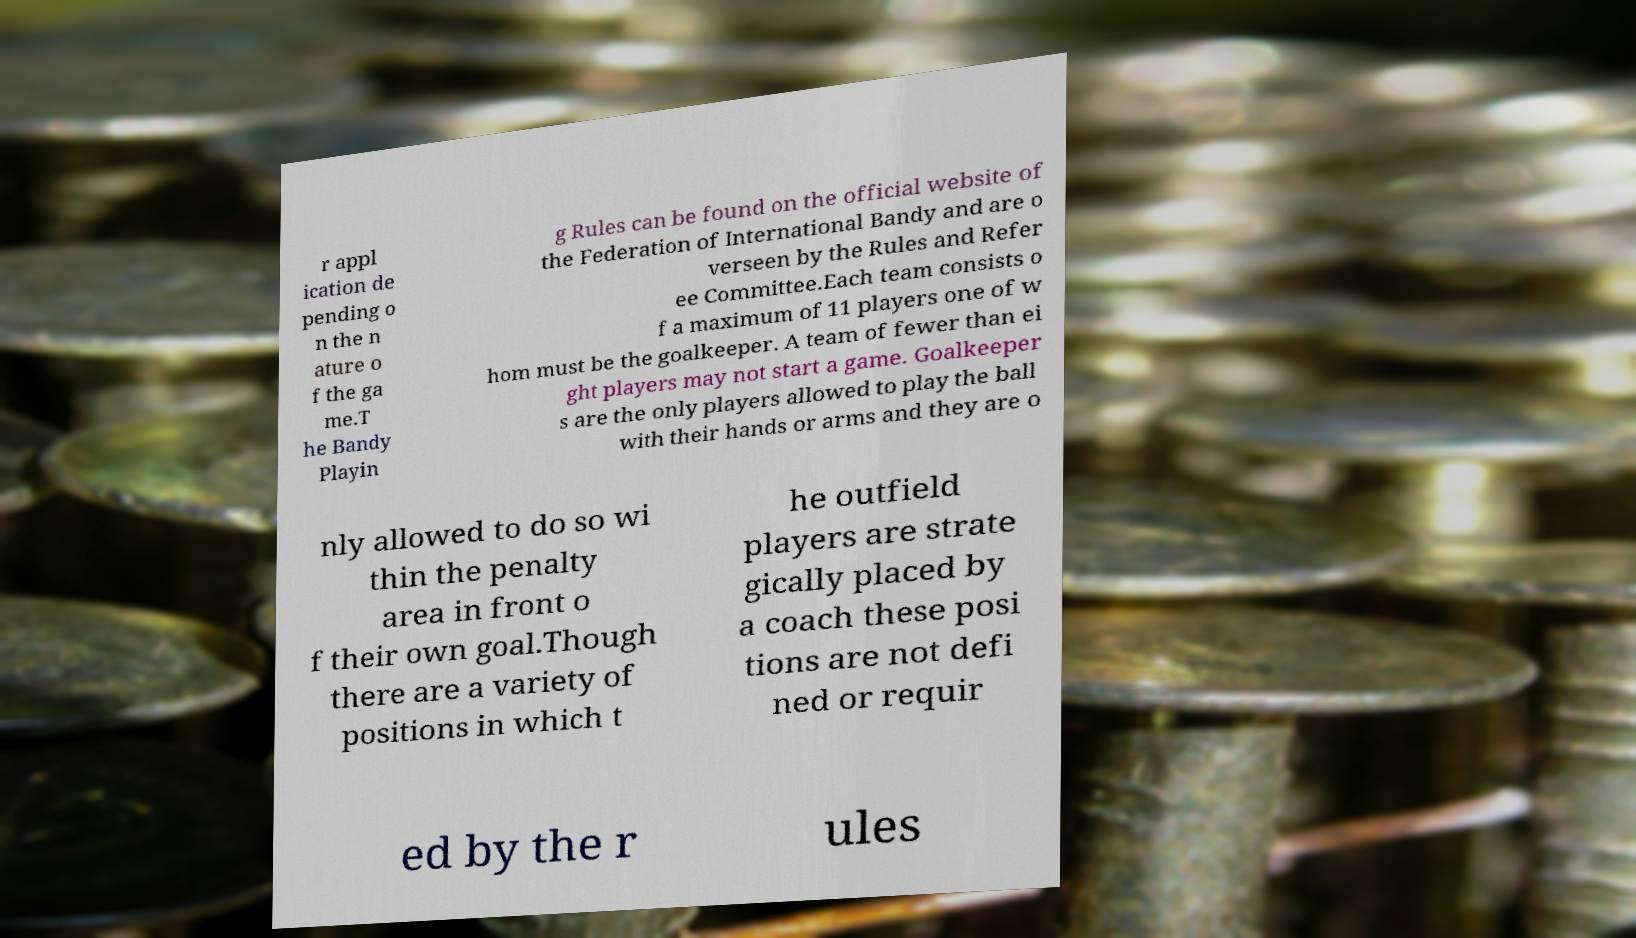Could you assist in decoding the text presented in this image and type it out clearly? r appl ication de pending o n the n ature o f the ga me.T he Bandy Playin g Rules can be found on the official website of the Federation of International Bandy and are o verseen by the Rules and Refer ee Committee.Each team consists o f a maximum of 11 players one of w hom must be the goalkeeper. A team of fewer than ei ght players may not start a game. Goalkeeper s are the only players allowed to play the ball with their hands or arms and they are o nly allowed to do so wi thin the penalty area in front o f their own goal.Though there are a variety of positions in which t he outfield players are strate gically placed by a coach these posi tions are not defi ned or requir ed by the r ules 